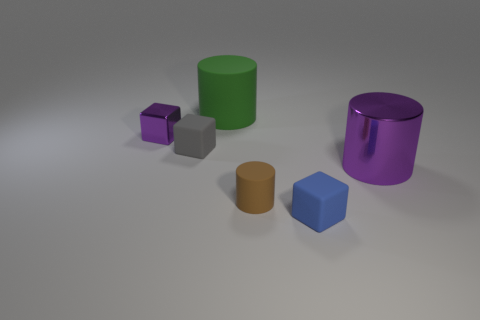Add 3 matte cubes. How many objects exist? 9 Subtract 0 purple spheres. How many objects are left? 6 Subtract all tiny gray cubes. Subtract all large purple cylinders. How many objects are left? 4 Add 2 small brown cylinders. How many small brown cylinders are left? 3 Add 4 large purple cylinders. How many large purple cylinders exist? 5 